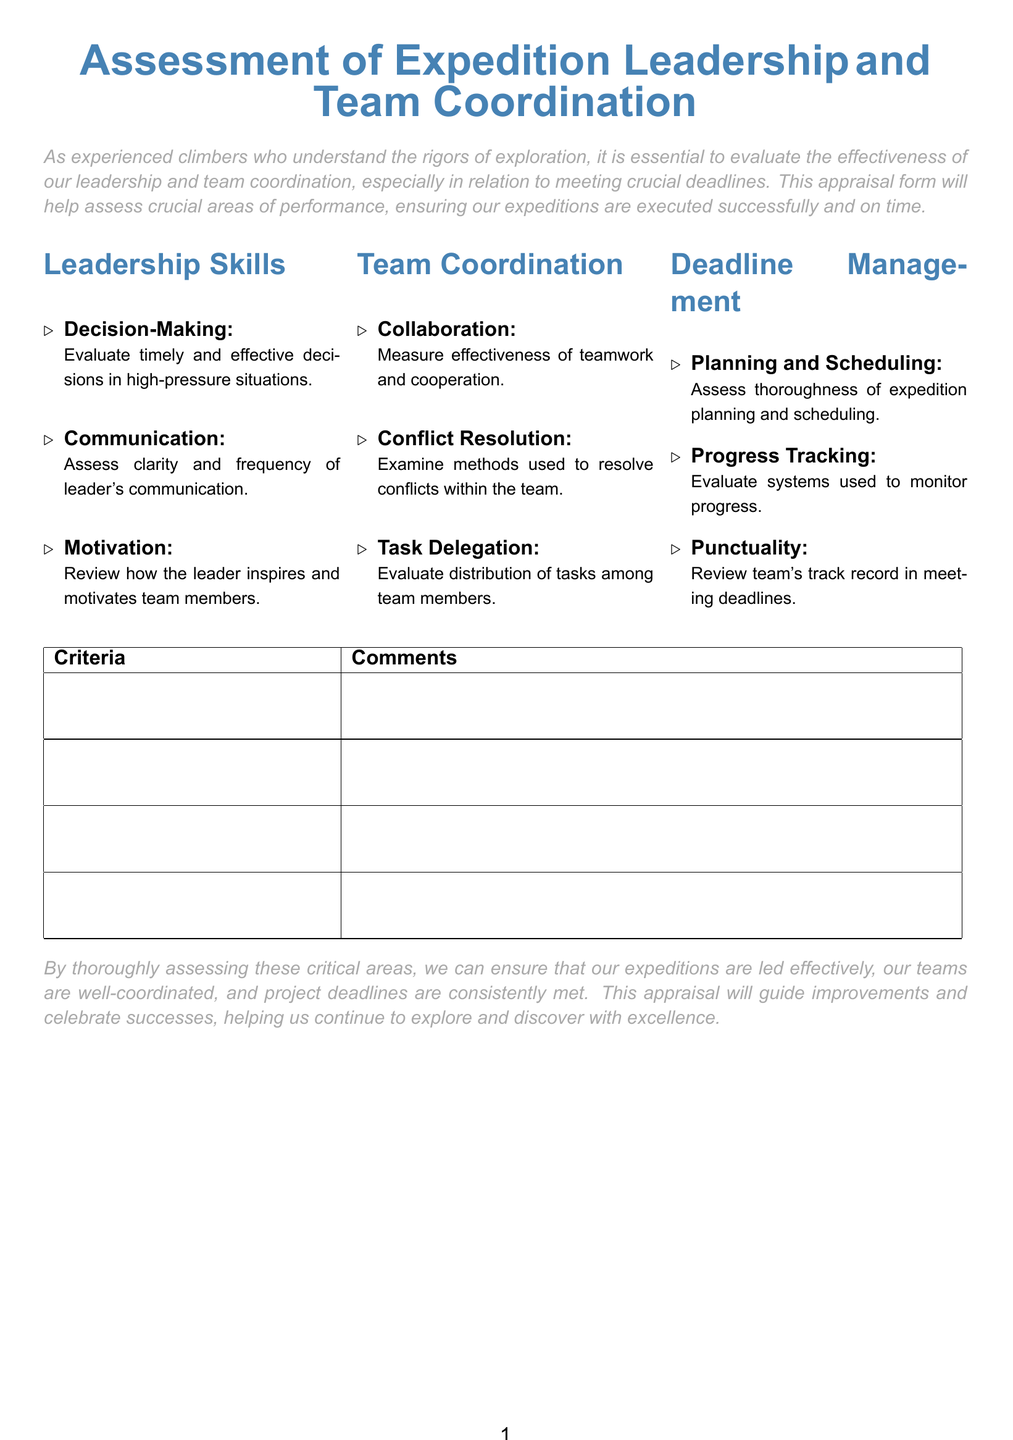What is the main focus of the appraisal form? The main focus is to evaluate the effectiveness of leadership and team coordination regarding meeting deadlines.
Answer: Effectiveness of leadership and team coordination How many sections are there in the appraisal form? The document contains three main sections: Leadership Skills, Team Coordination, and Deadline Management.
Answer: Three What does the 'Motivation' criterion assess? It assesses how the leader inspires and motivates team members.
Answer: Inspire and motivate team members What is one of the aspects evaluated under 'Progress Tracking'? The systems used to monitor progress are evaluated.
Answer: Systems used to monitor progress What color is used for section titles? The section titles are displayed in mountain blue color.
Answer: Mountain blue Which area includes 'Collaboration' as a criterion? 'Collaboration' is included under the Team Coordination section.
Answer: Team Coordination What should the appraisal lead to according to the conclusion? It should lead to improvements and celebrate successes.
Answer: Improvements and celebrate successes What is assessed under 'Planning and Scheduling'? The thoroughness of expedition planning and scheduling is assessed.
Answer: Thoroughness of planning and scheduling What does the appraisal form ultimately aim to ensure? It aims to ensure effective leadership, coordination, and meeting deadlines.
Answer: Effective leadership, coordination, and meeting deadlines 